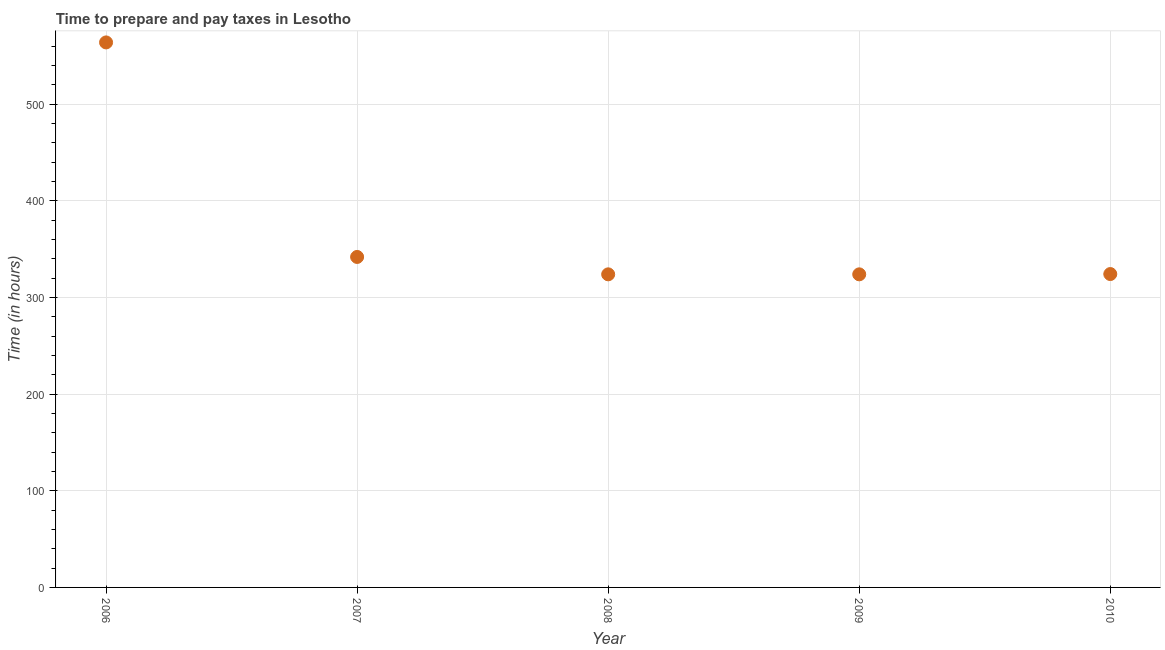What is the time to prepare and pay taxes in 2010?
Make the answer very short. 324.3. Across all years, what is the maximum time to prepare and pay taxes?
Offer a very short reply. 564. Across all years, what is the minimum time to prepare and pay taxes?
Provide a succinct answer. 324. What is the sum of the time to prepare and pay taxes?
Provide a short and direct response. 1878.3. What is the average time to prepare and pay taxes per year?
Give a very brief answer. 375.66. What is the median time to prepare and pay taxes?
Ensure brevity in your answer.  324.3. In how many years, is the time to prepare and pay taxes greater than 100 hours?
Offer a terse response. 5. What is the difference between the highest and the second highest time to prepare and pay taxes?
Provide a succinct answer. 222. Is the sum of the time to prepare and pay taxes in 2007 and 2010 greater than the maximum time to prepare and pay taxes across all years?
Your answer should be very brief. Yes. What is the difference between the highest and the lowest time to prepare and pay taxes?
Your answer should be very brief. 240. Does the graph contain grids?
Keep it short and to the point. Yes. What is the title of the graph?
Make the answer very short. Time to prepare and pay taxes in Lesotho. What is the label or title of the X-axis?
Provide a short and direct response. Year. What is the label or title of the Y-axis?
Your answer should be very brief. Time (in hours). What is the Time (in hours) in 2006?
Your response must be concise. 564. What is the Time (in hours) in 2007?
Provide a short and direct response. 342. What is the Time (in hours) in 2008?
Your answer should be compact. 324. What is the Time (in hours) in 2009?
Your answer should be compact. 324. What is the Time (in hours) in 2010?
Your response must be concise. 324.3. What is the difference between the Time (in hours) in 2006 and 2007?
Offer a terse response. 222. What is the difference between the Time (in hours) in 2006 and 2008?
Offer a terse response. 240. What is the difference between the Time (in hours) in 2006 and 2009?
Offer a terse response. 240. What is the difference between the Time (in hours) in 2006 and 2010?
Your answer should be compact. 239.7. What is the difference between the Time (in hours) in 2007 and 2009?
Provide a short and direct response. 18. What is the difference between the Time (in hours) in 2009 and 2010?
Offer a terse response. -0.3. What is the ratio of the Time (in hours) in 2006 to that in 2007?
Make the answer very short. 1.65. What is the ratio of the Time (in hours) in 2006 to that in 2008?
Your response must be concise. 1.74. What is the ratio of the Time (in hours) in 2006 to that in 2009?
Your answer should be compact. 1.74. What is the ratio of the Time (in hours) in 2006 to that in 2010?
Offer a terse response. 1.74. What is the ratio of the Time (in hours) in 2007 to that in 2008?
Your response must be concise. 1.06. What is the ratio of the Time (in hours) in 2007 to that in 2009?
Keep it short and to the point. 1.06. What is the ratio of the Time (in hours) in 2007 to that in 2010?
Your answer should be compact. 1.05. What is the ratio of the Time (in hours) in 2009 to that in 2010?
Offer a terse response. 1. 